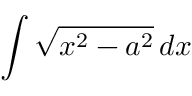<formula> <loc_0><loc_0><loc_500><loc_500>\int { \sqrt { x ^ { 2 } - a ^ { 2 } } } \, d x</formula> 